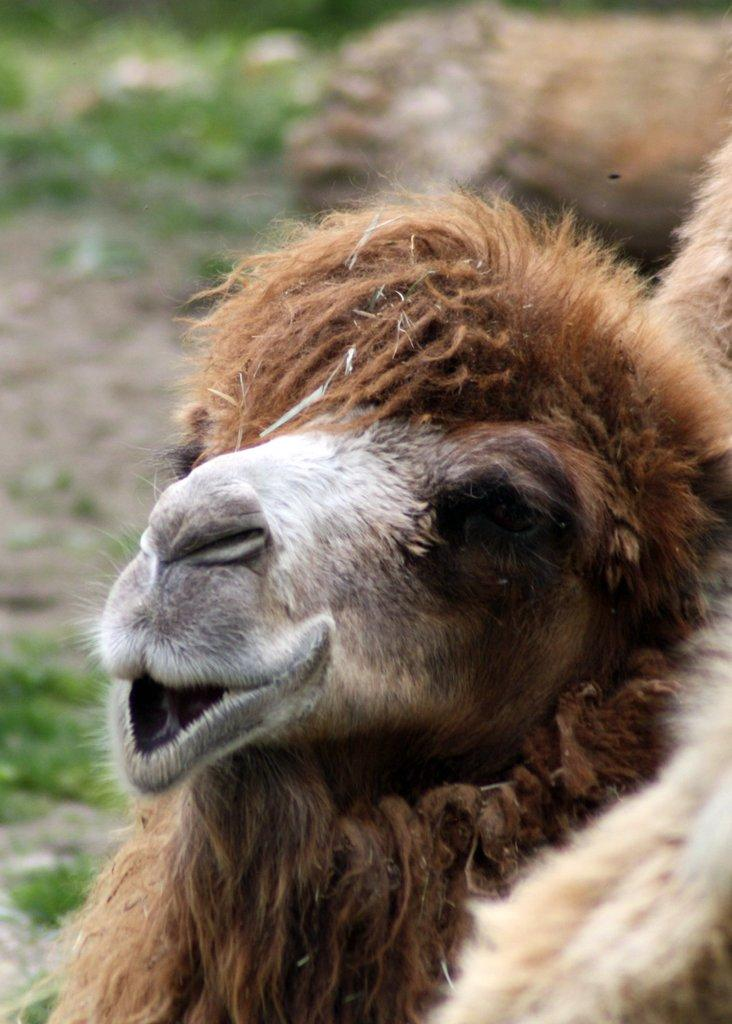What animal is the main subject of the image? There is a camel in the image. Can you describe the background of the image? The background of the image is blurred. What type of disgust can be seen on the camel's face in the image? There is no indication of any emotion, including disgust, on the camel's face in the image. 